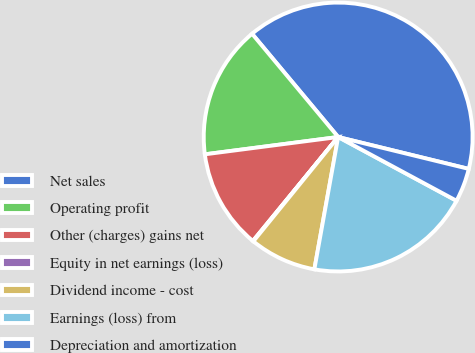Convert chart to OTSL. <chart><loc_0><loc_0><loc_500><loc_500><pie_chart><fcel>Net sales<fcel>Operating profit<fcel>Other (charges) gains net<fcel>Equity in net earnings (loss)<fcel>Dividend income - cost<fcel>Earnings (loss) from<fcel>Depreciation and amortization<nl><fcel>39.87%<fcel>15.99%<fcel>12.01%<fcel>0.07%<fcel>8.03%<fcel>19.97%<fcel>4.05%<nl></chart> 